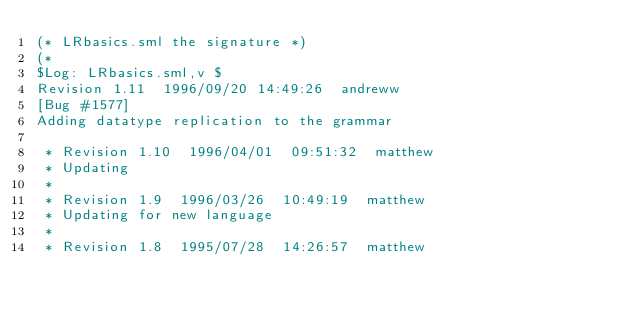Convert code to text. <code><loc_0><loc_0><loc_500><loc_500><_SML_>(* LRbasics.sml the signature *)
(*
$Log: LRbasics.sml,v $
Revision 1.11  1996/09/20 14:49:26  andreww
[Bug #1577]
Adding datatype replication to the grammar

 * Revision 1.10  1996/04/01  09:51:32  matthew
 * Updating
 *
 * Revision 1.9  1996/03/26  10:49:19  matthew
 * Updating for new language
 *
 * Revision 1.8  1995/07/28  14:26:57  matthew</code> 